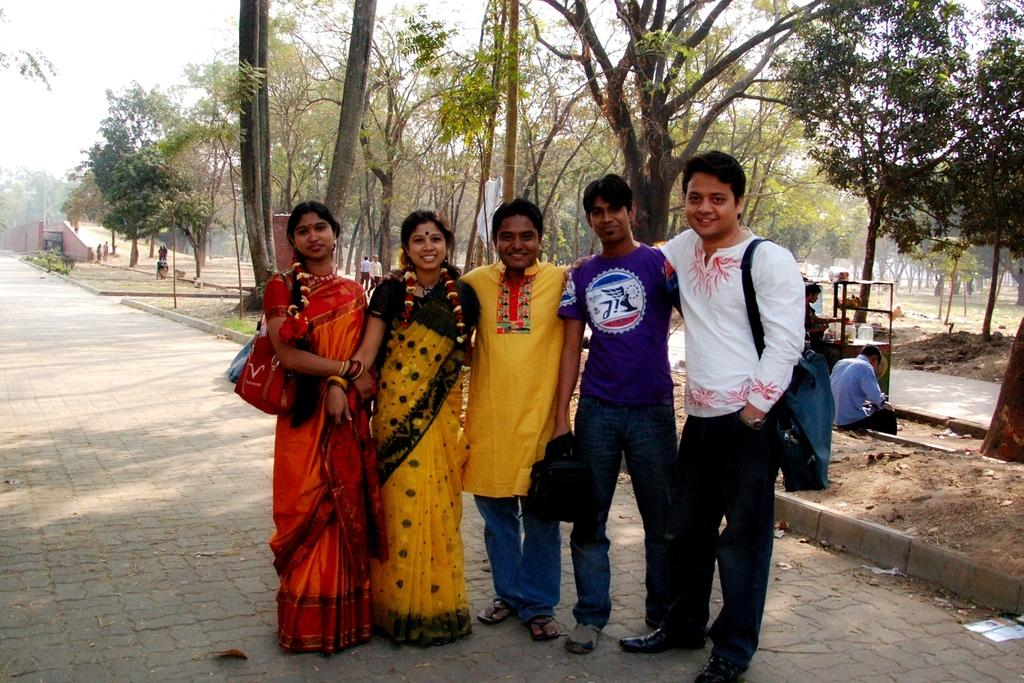What are the people in the image doing? There are persons standing on the ground in the image. What can be seen in the background of the image? In the background, there is a street vendor, a person sitting on the footpath, trees, buildings, and the sky. What letter is the woman holding in the image? There is no woman holding a letter in the image. How does the person sitting on the footpath fall in the image? The person sitting on the footpath does not fall in the image; they are sitting down. 